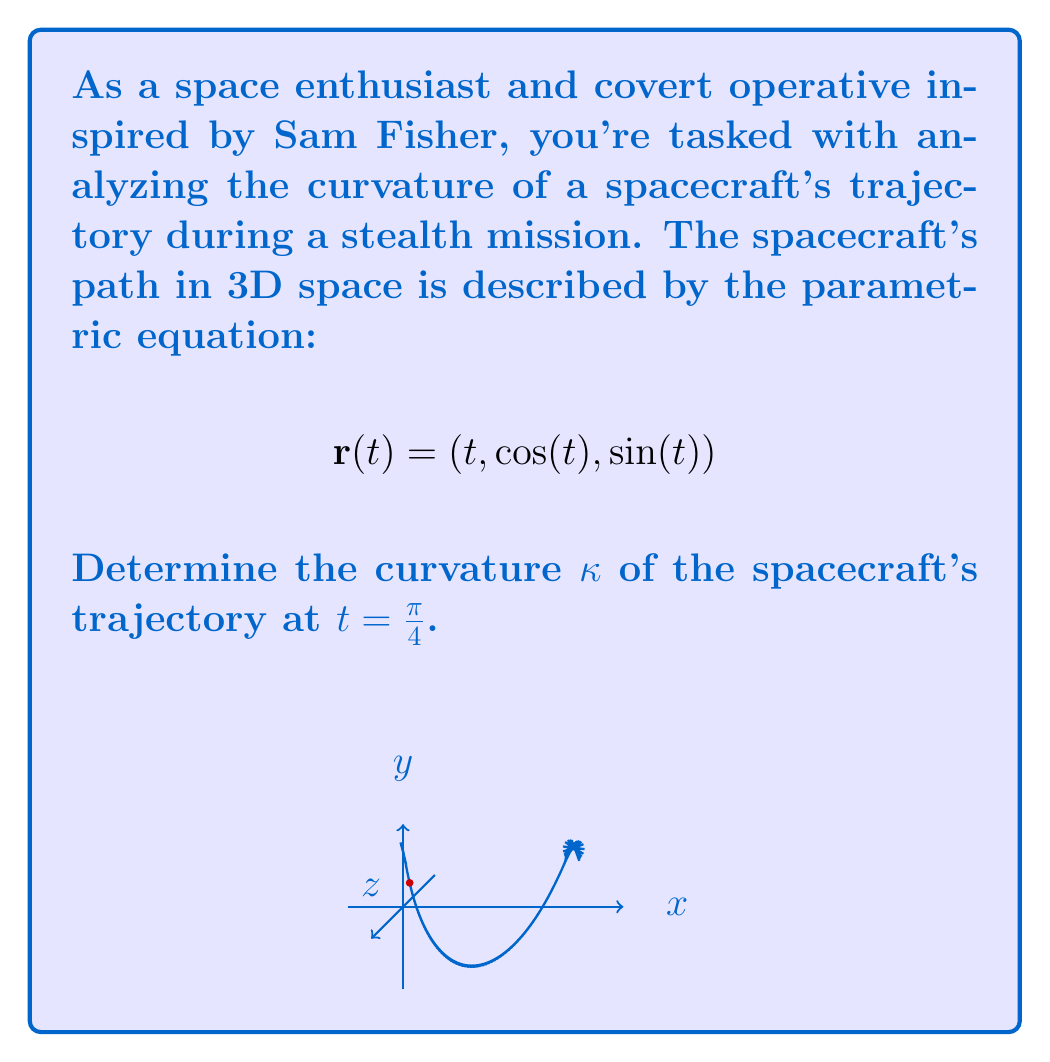Can you solve this math problem? To find the curvature of the spacecraft's trajectory, we'll use the formula for curvature in 3D space:

$$κ = \frac{|\mathbf{r}'(t) × \mathbf{r}''(t)|}{|\mathbf{r}'(t)|^3}$$

Step 1: Calculate r'(t)
$$\mathbf{r}'(t) = (1, -\sin(t), \cos(t))$$

Step 2: Calculate r''(t)
$$\mathbf{r}''(t) = (0, -\cos(t), -\sin(t))$$

Step 3: Evaluate r'(t) and r''(t) at t = π/4
$$\mathbf{r}'(\frac{\pi}{4}) = (1, -\frac{\sqrt{2}}{2}, \frac{\sqrt{2}}{2})$$
$$\mathbf{r}''(\frac{\pi}{4}) = (0, -\frac{\sqrt{2}}{2}, -\frac{\sqrt{2}}{2})$$

Step 4: Calculate the cross product r'(π/4) × r''(π/4)
$$\mathbf{r}'(\frac{\pi}{4}) × \mathbf{r}''(\frac{\pi}{4}) = \begin{vmatrix} 
\mathbf{i} & \mathbf{j} & \mathbf{k} \\
1 & -\frac{\sqrt{2}}{2} & \frac{\sqrt{2}}{2} \\
0 & -\frac{\sqrt{2}}{2} & -\frac{\sqrt{2}}{2}
\end{vmatrix} = (-\frac{1}{2}, -\frac{\sqrt{2}}{2}, \frac{\sqrt{2}}{2})$$

Step 5: Calculate |r'(π/4) × r''(π/4)|
$$|\mathbf{r}'(\frac{\pi}{4}) × \mathbf{r}''(\frac{\pi}{4})| = \sqrt{(\frac{1}{2})^2 + (\frac{\sqrt{2}}{2})^2 + (\frac{\sqrt{2}}{2})^2} = \sqrt{\frac{1}{4} + \frac{1}{2} + \frac{1}{2}} = 1$$

Step 6: Calculate |r'(π/4)|
$$|\mathbf{r}'(\frac{\pi}{4})| = \sqrt{1^2 + (\frac{\sqrt{2}}{2})^2 + (\frac{\sqrt{2}}{2})^2} = \sqrt{1 + \frac{1}{2} + \frac{1}{2}} = \sqrt{2}$$

Step 7: Apply the curvature formula
$$κ = \frac{|\mathbf{r}'(\frac{\pi}{4}) × \mathbf{r}''(\frac{\pi}{4})|}{|\mathbf{r}'(\frac{\pi}{4})|^3} = \frac{1}{(\sqrt{2})^3} = \frac{1}{2\sqrt{2}}$$
Answer: $\frac{1}{2\sqrt{2}}$ 